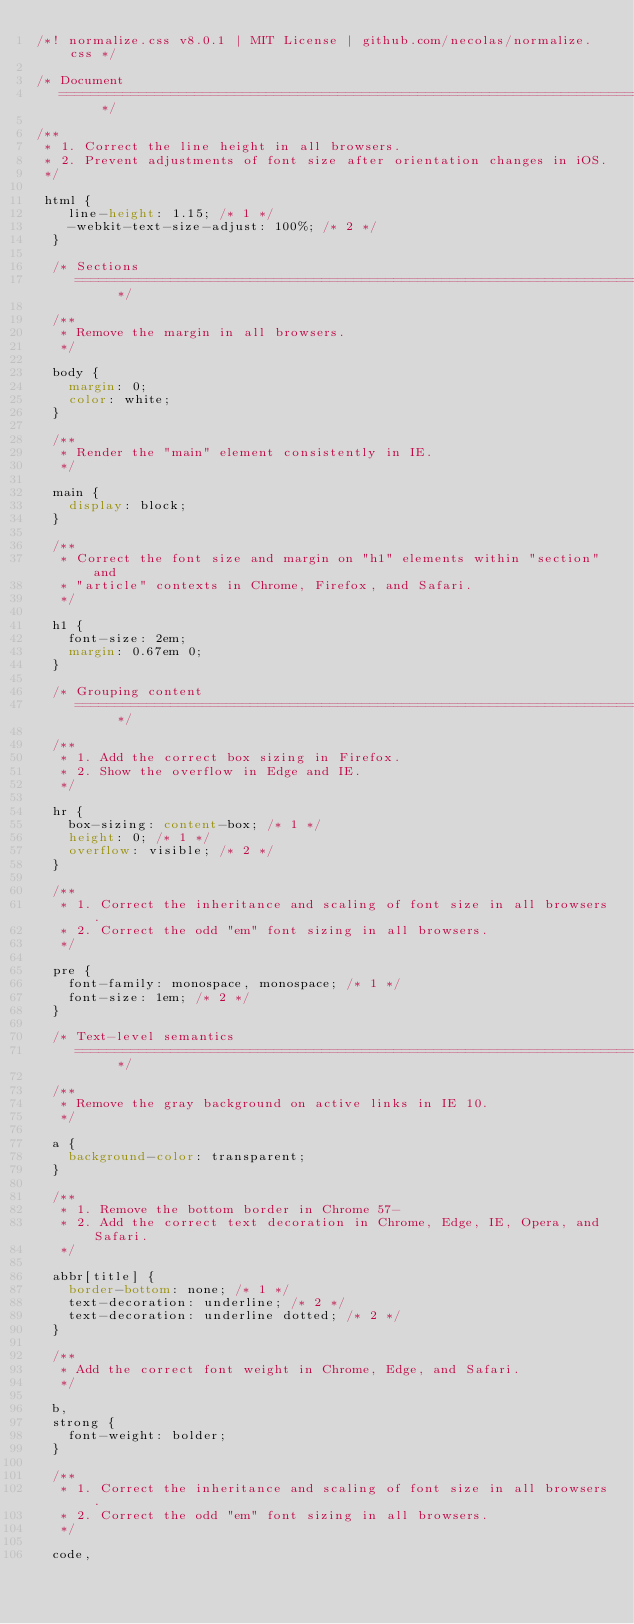<code> <loc_0><loc_0><loc_500><loc_500><_CSS_>/*! normalize.css v8.0.1 | MIT License | github.com/necolas/normalize.css */

/* Document
   ========================================================================== */

/**
 * 1. Correct the line height in all browsers.
 * 2. Prevent adjustments of font size after orientation changes in iOS.
 */

 html {
    line-height: 1.15; /* 1 */
    -webkit-text-size-adjust: 100%; /* 2 */
  }
  
  /* Sections
     ========================================================================== */
  
  /**
   * Remove the margin in all browsers.
   */
  
  body {
    margin: 0;
    color: white;
  }
  
  /**
   * Render the "main" element consistently in IE.
   */
  
  main {
    display: block;
  }
  
  /**
   * Correct the font size and margin on "h1" elements within "section" and
   * "article" contexts in Chrome, Firefox, and Safari.
   */
  
  h1 {
    font-size: 2em;
    margin: 0.67em 0;
  }
  
  /* Grouping content
     ========================================================================== */
  
  /**
   * 1. Add the correct box sizing in Firefox.
   * 2. Show the overflow in Edge and IE.
   */
  
  hr {
    box-sizing: content-box; /* 1 */
    height: 0; /* 1 */
    overflow: visible; /* 2 */
  }
  
  /**
   * 1. Correct the inheritance and scaling of font size in all browsers.
   * 2. Correct the odd "em" font sizing in all browsers.
   */
  
  pre {
    font-family: monospace, monospace; /* 1 */
    font-size: 1em; /* 2 */
  }
  
  /* Text-level semantics
     ========================================================================== */
  
  /**
   * Remove the gray background on active links in IE 10.
   */
  
  a {
    background-color: transparent;
  }
  
  /**
   * 1. Remove the bottom border in Chrome 57-
   * 2. Add the correct text decoration in Chrome, Edge, IE, Opera, and Safari.
   */
  
  abbr[title] {
    border-bottom: none; /* 1 */
    text-decoration: underline; /* 2 */
    text-decoration: underline dotted; /* 2 */
  }
  
  /**
   * Add the correct font weight in Chrome, Edge, and Safari.
   */
  
  b,
  strong {
    font-weight: bolder;
  }
  
  /**
   * 1. Correct the inheritance and scaling of font size in all browsers.
   * 2. Correct the odd "em" font sizing in all browsers.
   */
  
  code,</code> 